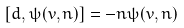Convert formula to latex. <formula><loc_0><loc_0><loc_500><loc_500>[ d , \psi ( v , n ) ] = - n \psi ( v , n )</formula> 